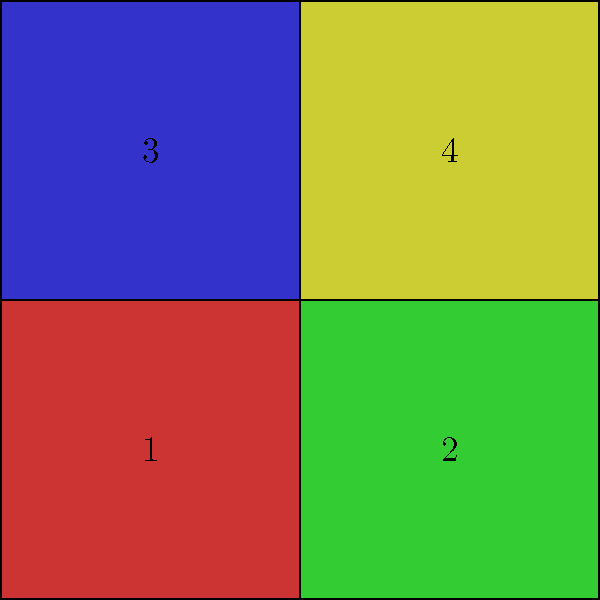Your child is working on a digital security puzzle where they need to arrange colored blocks to form a protective firewall. The image shows four colored squares labeled 1 to 4. If the firewall requires the red block (1) to be in the top-right corner for maximum security, how many 90-degree rotations of the entire square are needed to achieve this? Let's approach this step-by-step:

1. First, we need to identify the current position of the red block (1). It's in the bottom-left corner.

2. We need to move it to the top-right corner.

3. Each 90-degree rotation moves a corner piece to an adjacent corner:
   - 1st rotation (90°): bottom-left to bottom-right
   - 2nd rotation (180°): bottom-right to top-right

4. Therefore, we need two 90-degree rotations to move the red block from the bottom-left to the top-right corner.

This solution also ensures that the child understands the concept of rotational symmetry, which is often used in encryption and security algorithms.
Answer: 2 rotations 